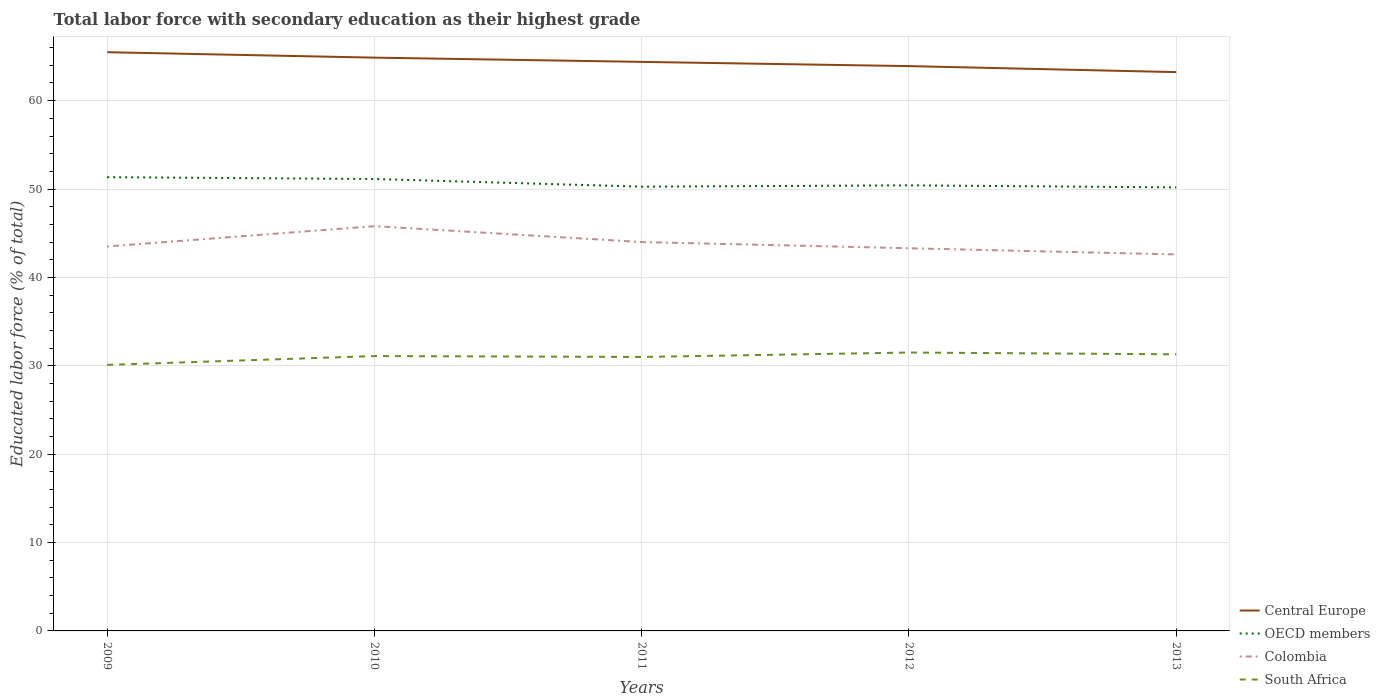Is the number of lines equal to the number of legend labels?
Make the answer very short. Yes. Across all years, what is the maximum percentage of total labor force with primary education in Colombia?
Provide a succinct answer. 42.6. What is the total percentage of total labor force with primary education in South Africa in the graph?
Provide a short and direct response. -0.4. What is the difference between the highest and the second highest percentage of total labor force with primary education in OECD members?
Your answer should be very brief. 1.15. What is the difference between the highest and the lowest percentage of total labor force with primary education in OECD members?
Keep it short and to the point. 2. What is the difference between two consecutive major ticks on the Y-axis?
Provide a short and direct response. 10. Are the values on the major ticks of Y-axis written in scientific E-notation?
Give a very brief answer. No. Does the graph contain any zero values?
Offer a terse response. No. Does the graph contain grids?
Your response must be concise. Yes. Where does the legend appear in the graph?
Your answer should be compact. Bottom right. What is the title of the graph?
Ensure brevity in your answer.  Total labor force with secondary education as their highest grade. What is the label or title of the X-axis?
Keep it short and to the point. Years. What is the label or title of the Y-axis?
Provide a succinct answer. Educated labor force (% of total). What is the Educated labor force (% of total) of Central Europe in 2009?
Your answer should be very brief. 65.48. What is the Educated labor force (% of total) of OECD members in 2009?
Ensure brevity in your answer.  51.34. What is the Educated labor force (% of total) in Colombia in 2009?
Keep it short and to the point. 43.5. What is the Educated labor force (% of total) in South Africa in 2009?
Keep it short and to the point. 30.1. What is the Educated labor force (% of total) of Central Europe in 2010?
Offer a terse response. 64.87. What is the Educated labor force (% of total) in OECD members in 2010?
Make the answer very short. 51.13. What is the Educated labor force (% of total) of Colombia in 2010?
Offer a terse response. 45.8. What is the Educated labor force (% of total) in South Africa in 2010?
Make the answer very short. 31.1. What is the Educated labor force (% of total) in Central Europe in 2011?
Offer a terse response. 64.39. What is the Educated labor force (% of total) of OECD members in 2011?
Keep it short and to the point. 50.27. What is the Educated labor force (% of total) in Colombia in 2011?
Your answer should be very brief. 44. What is the Educated labor force (% of total) in South Africa in 2011?
Keep it short and to the point. 31. What is the Educated labor force (% of total) of Central Europe in 2012?
Give a very brief answer. 63.91. What is the Educated labor force (% of total) of OECD members in 2012?
Your response must be concise. 50.41. What is the Educated labor force (% of total) in Colombia in 2012?
Your response must be concise. 43.3. What is the Educated labor force (% of total) in South Africa in 2012?
Your answer should be very brief. 31.5. What is the Educated labor force (% of total) of Central Europe in 2013?
Your response must be concise. 63.23. What is the Educated labor force (% of total) in OECD members in 2013?
Offer a very short reply. 50.19. What is the Educated labor force (% of total) in Colombia in 2013?
Keep it short and to the point. 42.6. What is the Educated labor force (% of total) in South Africa in 2013?
Keep it short and to the point. 31.3. Across all years, what is the maximum Educated labor force (% of total) in Central Europe?
Offer a terse response. 65.48. Across all years, what is the maximum Educated labor force (% of total) in OECD members?
Ensure brevity in your answer.  51.34. Across all years, what is the maximum Educated labor force (% of total) in Colombia?
Your response must be concise. 45.8. Across all years, what is the maximum Educated labor force (% of total) of South Africa?
Your response must be concise. 31.5. Across all years, what is the minimum Educated labor force (% of total) of Central Europe?
Provide a short and direct response. 63.23. Across all years, what is the minimum Educated labor force (% of total) of OECD members?
Your answer should be compact. 50.19. Across all years, what is the minimum Educated labor force (% of total) in Colombia?
Offer a very short reply. 42.6. Across all years, what is the minimum Educated labor force (% of total) of South Africa?
Make the answer very short. 30.1. What is the total Educated labor force (% of total) of Central Europe in the graph?
Provide a short and direct response. 321.87. What is the total Educated labor force (% of total) in OECD members in the graph?
Give a very brief answer. 253.35. What is the total Educated labor force (% of total) of Colombia in the graph?
Offer a terse response. 219.2. What is the total Educated labor force (% of total) of South Africa in the graph?
Ensure brevity in your answer.  155. What is the difference between the Educated labor force (% of total) of Central Europe in 2009 and that in 2010?
Offer a terse response. 0.61. What is the difference between the Educated labor force (% of total) in OECD members in 2009 and that in 2010?
Provide a succinct answer. 0.21. What is the difference between the Educated labor force (% of total) in Central Europe in 2009 and that in 2011?
Your response must be concise. 1.09. What is the difference between the Educated labor force (% of total) of OECD members in 2009 and that in 2011?
Provide a succinct answer. 1.07. What is the difference between the Educated labor force (% of total) of Colombia in 2009 and that in 2011?
Your response must be concise. -0.5. What is the difference between the Educated labor force (% of total) of Central Europe in 2009 and that in 2012?
Your answer should be compact. 1.57. What is the difference between the Educated labor force (% of total) of OECD members in 2009 and that in 2012?
Your answer should be compact. 0.93. What is the difference between the Educated labor force (% of total) in Colombia in 2009 and that in 2012?
Give a very brief answer. 0.2. What is the difference between the Educated labor force (% of total) in South Africa in 2009 and that in 2012?
Provide a short and direct response. -1.4. What is the difference between the Educated labor force (% of total) in Central Europe in 2009 and that in 2013?
Offer a very short reply. 2.25. What is the difference between the Educated labor force (% of total) of OECD members in 2009 and that in 2013?
Ensure brevity in your answer.  1.15. What is the difference between the Educated labor force (% of total) of Colombia in 2009 and that in 2013?
Your response must be concise. 0.9. What is the difference between the Educated labor force (% of total) in Central Europe in 2010 and that in 2011?
Provide a short and direct response. 0.48. What is the difference between the Educated labor force (% of total) in OECD members in 2010 and that in 2011?
Offer a very short reply. 0.87. What is the difference between the Educated labor force (% of total) of Colombia in 2010 and that in 2011?
Provide a short and direct response. 1.8. What is the difference between the Educated labor force (% of total) of Central Europe in 2010 and that in 2012?
Provide a succinct answer. 0.96. What is the difference between the Educated labor force (% of total) of OECD members in 2010 and that in 2012?
Offer a terse response. 0.72. What is the difference between the Educated labor force (% of total) of South Africa in 2010 and that in 2012?
Your answer should be very brief. -0.4. What is the difference between the Educated labor force (% of total) in Central Europe in 2010 and that in 2013?
Offer a very short reply. 1.64. What is the difference between the Educated labor force (% of total) in OECD members in 2010 and that in 2013?
Give a very brief answer. 0.95. What is the difference between the Educated labor force (% of total) in Colombia in 2010 and that in 2013?
Offer a terse response. 3.2. What is the difference between the Educated labor force (% of total) in South Africa in 2010 and that in 2013?
Your answer should be compact. -0.2. What is the difference between the Educated labor force (% of total) in Central Europe in 2011 and that in 2012?
Give a very brief answer. 0.48. What is the difference between the Educated labor force (% of total) in OECD members in 2011 and that in 2012?
Your answer should be very brief. -0.15. What is the difference between the Educated labor force (% of total) in Colombia in 2011 and that in 2012?
Keep it short and to the point. 0.7. What is the difference between the Educated labor force (% of total) in South Africa in 2011 and that in 2012?
Provide a succinct answer. -0.5. What is the difference between the Educated labor force (% of total) of Central Europe in 2011 and that in 2013?
Give a very brief answer. 1.16. What is the difference between the Educated labor force (% of total) in OECD members in 2011 and that in 2013?
Your answer should be compact. 0.08. What is the difference between the Educated labor force (% of total) in Colombia in 2011 and that in 2013?
Make the answer very short. 1.4. What is the difference between the Educated labor force (% of total) in Central Europe in 2012 and that in 2013?
Provide a short and direct response. 0.68. What is the difference between the Educated labor force (% of total) of OECD members in 2012 and that in 2013?
Make the answer very short. 0.23. What is the difference between the Educated labor force (% of total) of South Africa in 2012 and that in 2013?
Keep it short and to the point. 0.2. What is the difference between the Educated labor force (% of total) in Central Europe in 2009 and the Educated labor force (% of total) in OECD members in 2010?
Provide a short and direct response. 14.35. What is the difference between the Educated labor force (% of total) of Central Europe in 2009 and the Educated labor force (% of total) of Colombia in 2010?
Keep it short and to the point. 19.68. What is the difference between the Educated labor force (% of total) of Central Europe in 2009 and the Educated labor force (% of total) of South Africa in 2010?
Make the answer very short. 34.38. What is the difference between the Educated labor force (% of total) in OECD members in 2009 and the Educated labor force (% of total) in Colombia in 2010?
Your response must be concise. 5.54. What is the difference between the Educated labor force (% of total) in OECD members in 2009 and the Educated labor force (% of total) in South Africa in 2010?
Keep it short and to the point. 20.24. What is the difference between the Educated labor force (% of total) of Colombia in 2009 and the Educated labor force (% of total) of South Africa in 2010?
Offer a terse response. 12.4. What is the difference between the Educated labor force (% of total) of Central Europe in 2009 and the Educated labor force (% of total) of OECD members in 2011?
Keep it short and to the point. 15.21. What is the difference between the Educated labor force (% of total) of Central Europe in 2009 and the Educated labor force (% of total) of Colombia in 2011?
Make the answer very short. 21.48. What is the difference between the Educated labor force (% of total) in Central Europe in 2009 and the Educated labor force (% of total) in South Africa in 2011?
Give a very brief answer. 34.48. What is the difference between the Educated labor force (% of total) of OECD members in 2009 and the Educated labor force (% of total) of Colombia in 2011?
Ensure brevity in your answer.  7.34. What is the difference between the Educated labor force (% of total) of OECD members in 2009 and the Educated labor force (% of total) of South Africa in 2011?
Offer a terse response. 20.34. What is the difference between the Educated labor force (% of total) of Colombia in 2009 and the Educated labor force (% of total) of South Africa in 2011?
Give a very brief answer. 12.5. What is the difference between the Educated labor force (% of total) of Central Europe in 2009 and the Educated labor force (% of total) of OECD members in 2012?
Give a very brief answer. 15.07. What is the difference between the Educated labor force (% of total) in Central Europe in 2009 and the Educated labor force (% of total) in Colombia in 2012?
Your answer should be compact. 22.18. What is the difference between the Educated labor force (% of total) of Central Europe in 2009 and the Educated labor force (% of total) of South Africa in 2012?
Keep it short and to the point. 33.98. What is the difference between the Educated labor force (% of total) in OECD members in 2009 and the Educated labor force (% of total) in Colombia in 2012?
Your response must be concise. 8.04. What is the difference between the Educated labor force (% of total) of OECD members in 2009 and the Educated labor force (% of total) of South Africa in 2012?
Your answer should be compact. 19.84. What is the difference between the Educated labor force (% of total) of Colombia in 2009 and the Educated labor force (% of total) of South Africa in 2012?
Provide a succinct answer. 12. What is the difference between the Educated labor force (% of total) of Central Europe in 2009 and the Educated labor force (% of total) of OECD members in 2013?
Your answer should be compact. 15.29. What is the difference between the Educated labor force (% of total) in Central Europe in 2009 and the Educated labor force (% of total) in Colombia in 2013?
Your answer should be compact. 22.88. What is the difference between the Educated labor force (% of total) of Central Europe in 2009 and the Educated labor force (% of total) of South Africa in 2013?
Make the answer very short. 34.18. What is the difference between the Educated labor force (% of total) of OECD members in 2009 and the Educated labor force (% of total) of Colombia in 2013?
Give a very brief answer. 8.74. What is the difference between the Educated labor force (% of total) in OECD members in 2009 and the Educated labor force (% of total) in South Africa in 2013?
Keep it short and to the point. 20.04. What is the difference between the Educated labor force (% of total) in Central Europe in 2010 and the Educated labor force (% of total) in OECD members in 2011?
Your response must be concise. 14.6. What is the difference between the Educated labor force (% of total) in Central Europe in 2010 and the Educated labor force (% of total) in Colombia in 2011?
Ensure brevity in your answer.  20.87. What is the difference between the Educated labor force (% of total) in Central Europe in 2010 and the Educated labor force (% of total) in South Africa in 2011?
Give a very brief answer. 33.87. What is the difference between the Educated labor force (% of total) of OECD members in 2010 and the Educated labor force (% of total) of Colombia in 2011?
Your answer should be very brief. 7.13. What is the difference between the Educated labor force (% of total) of OECD members in 2010 and the Educated labor force (% of total) of South Africa in 2011?
Provide a succinct answer. 20.13. What is the difference between the Educated labor force (% of total) of Colombia in 2010 and the Educated labor force (% of total) of South Africa in 2011?
Your response must be concise. 14.8. What is the difference between the Educated labor force (% of total) of Central Europe in 2010 and the Educated labor force (% of total) of OECD members in 2012?
Provide a succinct answer. 14.45. What is the difference between the Educated labor force (% of total) in Central Europe in 2010 and the Educated labor force (% of total) in Colombia in 2012?
Your answer should be compact. 21.57. What is the difference between the Educated labor force (% of total) in Central Europe in 2010 and the Educated labor force (% of total) in South Africa in 2012?
Offer a very short reply. 33.37. What is the difference between the Educated labor force (% of total) in OECD members in 2010 and the Educated labor force (% of total) in Colombia in 2012?
Keep it short and to the point. 7.83. What is the difference between the Educated labor force (% of total) in OECD members in 2010 and the Educated labor force (% of total) in South Africa in 2012?
Your answer should be compact. 19.63. What is the difference between the Educated labor force (% of total) of Colombia in 2010 and the Educated labor force (% of total) of South Africa in 2012?
Keep it short and to the point. 14.3. What is the difference between the Educated labor force (% of total) in Central Europe in 2010 and the Educated labor force (% of total) in OECD members in 2013?
Ensure brevity in your answer.  14.68. What is the difference between the Educated labor force (% of total) of Central Europe in 2010 and the Educated labor force (% of total) of Colombia in 2013?
Make the answer very short. 22.27. What is the difference between the Educated labor force (% of total) of Central Europe in 2010 and the Educated labor force (% of total) of South Africa in 2013?
Ensure brevity in your answer.  33.57. What is the difference between the Educated labor force (% of total) in OECD members in 2010 and the Educated labor force (% of total) in Colombia in 2013?
Provide a short and direct response. 8.53. What is the difference between the Educated labor force (% of total) in OECD members in 2010 and the Educated labor force (% of total) in South Africa in 2013?
Give a very brief answer. 19.83. What is the difference between the Educated labor force (% of total) of Central Europe in 2011 and the Educated labor force (% of total) of OECD members in 2012?
Give a very brief answer. 13.97. What is the difference between the Educated labor force (% of total) of Central Europe in 2011 and the Educated labor force (% of total) of Colombia in 2012?
Offer a very short reply. 21.09. What is the difference between the Educated labor force (% of total) in Central Europe in 2011 and the Educated labor force (% of total) in South Africa in 2012?
Your answer should be compact. 32.89. What is the difference between the Educated labor force (% of total) in OECD members in 2011 and the Educated labor force (% of total) in Colombia in 2012?
Offer a terse response. 6.97. What is the difference between the Educated labor force (% of total) of OECD members in 2011 and the Educated labor force (% of total) of South Africa in 2012?
Provide a short and direct response. 18.77. What is the difference between the Educated labor force (% of total) in Colombia in 2011 and the Educated labor force (% of total) in South Africa in 2012?
Keep it short and to the point. 12.5. What is the difference between the Educated labor force (% of total) in Central Europe in 2011 and the Educated labor force (% of total) in OECD members in 2013?
Provide a short and direct response. 14.2. What is the difference between the Educated labor force (% of total) of Central Europe in 2011 and the Educated labor force (% of total) of Colombia in 2013?
Provide a succinct answer. 21.79. What is the difference between the Educated labor force (% of total) in Central Europe in 2011 and the Educated labor force (% of total) in South Africa in 2013?
Give a very brief answer. 33.09. What is the difference between the Educated labor force (% of total) of OECD members in 2011 and the Educated labor force (% of total) of Colombia in 2013?
Provide a short and direct response. 7.67. What is the difference between the Educated labor force (% of total) in OECD members in 2011 and the Educated labor force (% of total) in South Africa in 2013?
Give a very brief answer. 18.97. What is the difference between the Educated labor force (% of total) of Colombia in 2011 and the Educated labor force (% of total) of South Africa in 2013?
Your answer should be compact. 12.7. What is the difference between the Educated labor force (% of total) in Central Europe in 2012 and the Educated labor force (% of total) in OECD members in 2013?
Give a very brief answer. 13.72. What is the difference between the Educated labor force (% of total) in Central Europe in 2012 and the Educated labor force (% of total) in Colombia in 2013?
Your answer should be compact. 21.31. What is the difference between the Educated labor force (% of total) in Central Europe in 2012 and the Educated labor force (% of total) in South Africa in 2013?
Ensure brevity in your answer.  32.61. What is the difference between the Educated labor force (% of total) in OECD members in 2012 and the Educated labor force (% of total) in Colombia in 2013?
Your response must be concise. 7.81. What is the difference between the Educated labor force (% of total) of OECD members in 2012 and the Educated labor force (% of total) of South Africa in 2013?
Offer a very short reply. 19.11. What is the average Educated labor force (% of total) of Central Europe per year?
Give a very brief answer. 64.37. What is the average Educated labor force (% of total) in OECD members per year?
Offer a very short reply. 50.67. What is the average Educated labor force (% of total) in Colombia per year?
Provide a short and direct response. 43.84. What is the average Educated labor force (% of total) of South Africa per year?
Your answer should be very brief. 31. In the year 2009, what is the difference between the Educated labor force (% of total) of Central Europe and Educated labor force (% of total) of OECD members?
Offer a very short reply. 14.14. In the year 2009, what is the difference between the Educated labor force (% of total) in Central Europe and Educated labor force (% of total) in Colombia?
Ensure brevity in your answer.  21.98. In the year 2009, what is the difference between the Educated labor force (% of total) in Central Europe and Educated labor force (% of total) in South Africa?
Offer a terse response. 35.38. In the year 2009, what is the difference between the Educated labor force (% of total) in OECD members and Educated labor force (% of total) in Colombia?
Provide a succinct answer. 7.84. In the year 2009, what is the difference between the Educated labor force (% of total) of OECD members and Educated labor force (% of total) of South Africa?
Provide a succinct answer. 21.24. In the year 2009, what is the difference between the Educated labor force (% of total) of Colombia and Educated labor force (% of total) of South Africa?
Keep it short and to the point. 13.4. In the year 2010, what is the difference between the Educated labor force (% of total) in Central Europe and Educated labor force (% of total) in OECD members?
Provide a short and direct response. 13.73. In the year 2010, what is the difference between the Educated labor force (% of total) of Central Europe and Educated labor force (% of total) of Colombia?
Your response must be concise. 19.07. In the year 2010, what is the difference between the Educated labor force (% of total) of Central Europe and Educated labor force (% of total) of South Africa?
Provide a short and direct response. 33.77. In the year 2010, what is the difference between the Educated labor force (% of total) in OECD members and Educated labor force (% of total) in Colombia?
Give a very brief answer. 5.33. In the year 2010, what is the difference between the Educated labor force (% of total) of OECD members and Educated labor force (% of total) of South Africa?
Ensure brevity in your answer.  20.03. In the year 2011, what is the difference between the Educated labor force (% of total) of Central Europe and Educated labor force (% of total) of OECD members?
Offer a terse response. 14.12. In the year 2011, what is the difference between the Educated labor force (% of total) of Central Europe and Educated labor force (% of total) of Colombia?
Offer a terse response. 20.39. In the year 2011, what is the difference between the Educated labor force (% of total) of Central Europe and Educated labor force (% of total) of South Africa?
Provide a succinct answer. 33.39. In the year 2011, what is the difference between the Educated labor force (% of total) of OECD members and Educated labor force (% of total) of Colombia?
Provide a succinct answer. 6.27. In the year 2011, what is the difference between the Educated labor force (% of total) in OECD members and Educated labor force (% of total) in South Africa?
Keep it short and to the point. 19.27. In the year 2012, what is the difference between the Educated labor force (% of total) of Central Europe and Educated labor force (% of total) of OECD members?
Provide a short and direct response. 13.49. In the year 2012, what is the difference between the Educated labor force (% of total) in Central Europe and Educated labor force (% of total) in Colombia?
Offer a very short reply. 20.61. In the year 2012, what is the difference between the Educated labor force (% of total) in Central Europe and Educated labor force (% of total) in South Africa?
Your answer should be very brief. 32.41. In the year 2012, what is the difference between the Educated labor force (% of total) in OECD members and Educated labor force (% of total) in Colombia?
Provide a short and direct response. 7.11. In the year 2012, what is the difference between the Educated labor force (% of total) of OECD members and Educated labor force (% of total) of South Africa?
Provide a short and direct response. 18.91. In the year 2013, what is the difference between the Educated labor force (% of total) in Central Europe and Educated labor force (% of total) in OECD members?
Your answer should be compact. 13.04. In the year 2013, what is the difference between the Educated labor force (% of total) in Central Europe and Educated labor force (% of total) in Colombia?
Provide a short and direct response. 20.63. In the year 2013, what is the difference between the Educated labor force (% of total) in Central Europe and Educated labor force (% of total) in South Africa?
Provide a succinct answer. 31.93. In the year 2013, what is the difference between the Educated labor force (% of total) of OECD members and Educated labor force (% of total) of Colombia?
Make the answer very short. 7.59. In the year 2013, what is the difference between the Educated labor force (% of total) in OECD members and Educated labor force (% of total) in South Africa?
Provide a succinct answer. 18.89. What is the ratio of the Educated labor force (% of total) of Central Europe in 2009 to that in 2010?
Provide a succinct answer. 1.01. What is the ratio of the Educated labor force (% of total) in OECD members in 2009 to that in 2010?
Keep it short and to the point. 1. What is the ratio of the Educated labor force (% of total) in Colombia in 2009 to that in 2010?
Provide a succinct answer. 0.95. What is the ratio of the Educated labor force (% of total) in South Africa in 2009 to that in 2010?
Keep it short and to the point. 0.97. What is the ratio of the Educated labor force (% of total) of Central Europe in 2009 to that in 2011?
Your answer should be very brief. 1.02. What is the ratio of the Educated labor force (% of total) of OECD members in 2009 to that in 2011?
Your response must be concise. 1.02. What is the ratio of the Educated labor force (% of total) in Central Europe in 2009 to that in 2012?
Give a very brief answer. 1.02. What is the ratio of the Educated labor force (% of total) of OECD members in 2009 to that in 2012?
Provide a short and direct response. 1.02. What is the ratio of the Educated labor force (% of total) of Colombia in 2009 to that in 2012?
Your answer should be compact. 1. What is the ratio of the Educated labor force (% of total) of South Africa in 2009 to that in 2012?
Your answer should be compact. 0.96. What is the ratio of the Educated labor force (% of total) of Central Europe in 2009 to that in 2013?
Your answer should be compact. 1.04. What is the ratio of the Educated labor force (% of total) in OECD members in 2009 to that in 2013?
Make the answer very short. 1.02. What is the ratio of the Educated labor force (% of total) in Colombia in 2009 to that in 2013?
Your answer should be very brief. 1.02. What is the ratio of the Educated labor force (% of total) of South Africa in 2009 to that in 2013?
Provide a succinct answer. 0.96. What is the ratio of the Educated labor force (% of total) in Central Europe in 2010 to that in 2011?
Keep it short and to the point. 1.01. What is the ratio of the Educated labor force (% of total) of OECD members in 2010 to that in 2011?
Make the answer very short. 1.02. What is the ratio of the Educated labor force (% of total) in Colombia in 2010 to that in 2011?
Your response must be concise. 1.04. What is the ratio of the Educated labor force (% of total) of South Africa in 2010 to that in 2011?
Provide a short and direct response. 1. What is the ratio of the Educated labor force (% of total) in OECD members in 2010 to that in 2012?
Your answer should be very brief. 1.01. What is the ratio of the Educated labor force (% of total) in Colombia in 2010 to that in 2012?
Provide a succinct answer. 1.06. What is the ratio of the Educated labor force (% of total) in South Africa in 2010 to that in 2012?
Ensure brevity in your answer.  0.99. What is the ratio of the Educated labor force (% of total) of Central Europe in 2010 to that in 2013?
Keep it short and to the point. 1.03. What is the ratio of the Educated labor force (% of total) of OECD members in 2010 to that in 2013?
Your response must be concise. 1.02. What is the ratio of the Educated labor force (% of total) of Colombia in 2010 to that in 2013?
Your answer should be compact. 1.08. What is the ratio of the Educated labor force (% of total) of South Africa in 2010 to that in 2013?
Provide a short and direct response. 0.99. What is the ratio of the Educated labor force (% of total) of Central Europe in 2011 to that in 2012?
Give a very brief answer. 1.01. What is the ratio of the Educated labor force (% of total) of Colombia in 2011 to that in 2012?
Provide a succinct answer. 1.02. What is the ratio of the Educated labor force (% of total) in South Africa in 2011 to that in 2012?
Offer a terse response. 0.98. What is the ratio of the Educated labor force (% of total) of Central Europe in 2011 to that in 2013?
Provide a succinct answer. 1.02. What is the ratio of the Educated labor force (% of total) in Colombia in 2011 to that in 2013?
Offer a terse response. 1.03. What is the ratio of the Educated labor force (% of total) in South Africa in 2011 to that in 2013?
Your answer should be compact. 0.99. What is the ratio of the Educated labor force (% of total) in Central Europe in 2012 to that in 2013?
Provide a short and direct response. 1.01. What is the ratio of the Educated labor force (% of total) of OECD members in 2012 to that in 2013?
Your answer should be very brief. 1. What is the ratio of the Educated labor force (% of total) in Colombia in 2012 to that in 2013?
Offer a terse response. 1.02. What is the ratio of the Educated labor force (% of total) of South Africa in 2012 to that in 2013?
Offer a terse response. 1.01. What is the difference between the highest and the second highest Educated labor force (% of total) in Central Europe?
Your answer should be very brief. 0.61. What is the difference between the highest and the second highest Educated labor force (% of total) in OECD members?
Offer a terse response. 0.21. What is the difference between the highest and the second highest Educated labor force (% of total) in South Africa?
Provide a short and direct response. 0.2. What is the difference between the highest and the lowest Educated labor force (% of total) of Central Europe?
Ensure brevity in your answer.  2.25. What is the difference between the highest and the lowest Educated labor force (% of total) of OECD members?
Give a very brief answer. 1.15. What is the difference between the highest and the lowest Educated labor force (% of total) in Colombia?
Make the answer very short. 3.2. What is the difference between the highest and the lowest Educated labor force (% of total) in South Africa?
Make the answer very short. 1.4. 